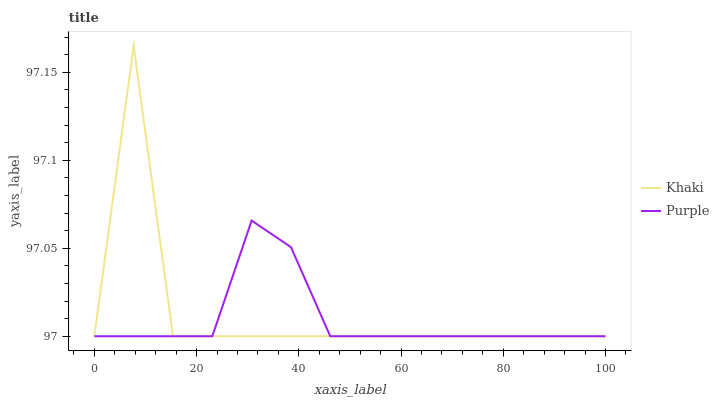Does Purple have the minimum area under the curve?
Answer yes or no. Yes. Does Khaki have the maximum area under the curve?
Answer yes or no. Yes. Does Khaki have the minimum area under the curve?
Answer yes or no. No. Is Purple the smoothest?
Answer yes or no. Yes. Is Khaki the roughest?
Answer yes or no. Yes. Is Khaki the smoothest?
Answer yes or no. No. Does Purple have the lowest value?
Answer yes or no. Yes. Does Khaki have the highest value?
Answer yes or no. Yes. Does Khaki intersect Purple?
Answer yes or no. Yes. Is Khaki less than Purple?
Answer yes or no. No. Is Khaki greater than Purple?
Answer yes or no. No. 